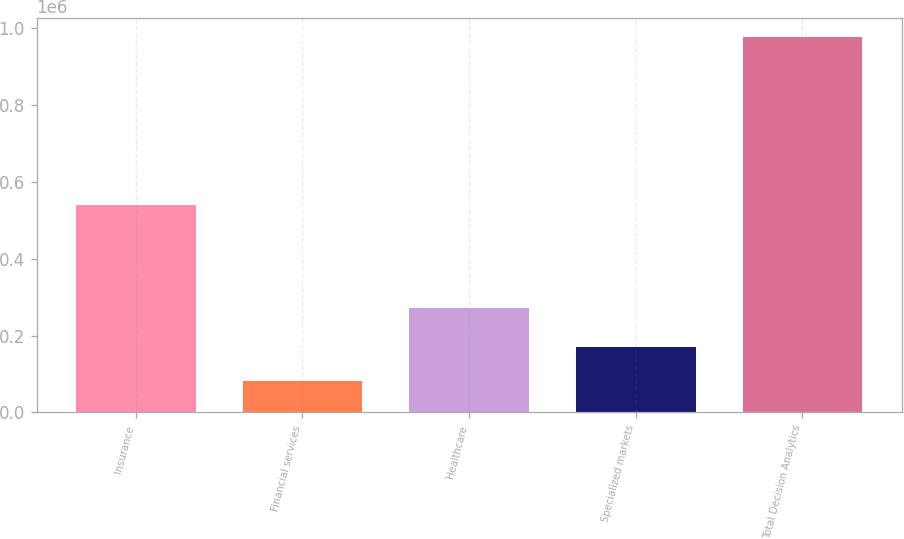Convert chart. <chart><loc_0><loc_0><loc_500><loc_500><bar_chart><fcel>Insurance<fcel>Financial services<fcel>Healthcare<fcel>Specialized markets<fcel>Total Decision Analytics<nl><fcel>539150<fcel>81113<fcel>271538<fcel>170744<fcel>977427<nl></chart> 